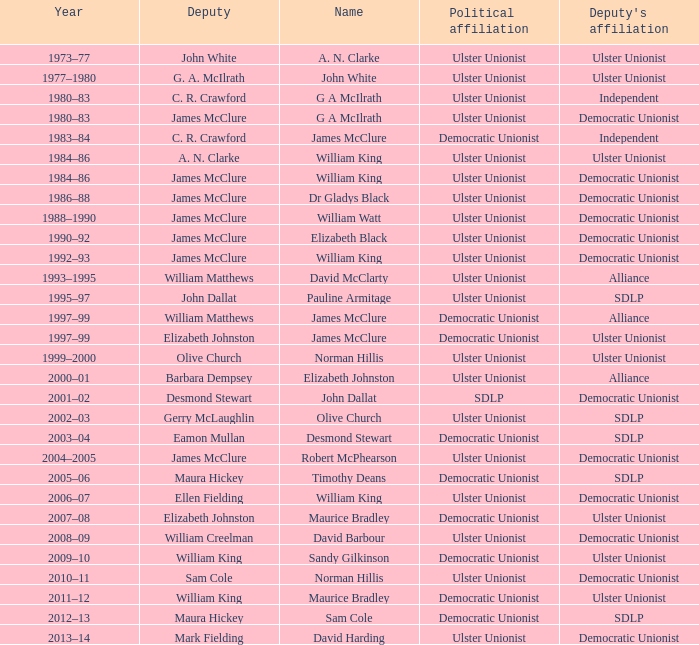Parse the full table. {'header': ['Year', 'Deputy', 'Name', 'Political affiliation', "Deputy's affiliation"], 'rows': [['1973–77', 'John White', 'A. N. Clarke', 'Ulster Unionist', 'Ulster Unionist'], ['1977–1980', 'G. A. McIlrath', 'John White', 'Ulster Unionist', 'Ulster Unionist'], ['1980–83', 'C. R. Crawford', 'G A McIlrath', 'Ulster Unionist', 'Independent'], ['1980–83', 'James McClure', 'G A McIlrath', 'Ulster Unionist', 'Democratic Unionist'], ['1983–84', 'C. R. Crawford', 'James McClure', 'Democratic Unionist', 'Independent'], ['1984–86', 'A. N. Clarke', 'William King', 'Ulster Unionist', 'Ulster Unionist'], ['1984–86', 'James McClure', 'William King', 'Ulster Unionist', 'Democratic Unionist'], ['1986–88', 'James McClure', 'Dr Gladys Black', 'Ulster Unionist', 'Democratic Unionist'], ['1988–1990', 'James McClure', 'William Watt', 'Ulster Unionist', 'Democratic Unionist'], ['1990–92', 'James McClure', 'Elizabeth Black', 'Ulster Unionist', 'Democratic Unionist'], ['1992–93', 'James McClure', 'William King', 'Ulster Unionist', 'Democratic Unionist'], ['1993–1995', 'William Matthews', 'David McClarty', 'Ulster Unionist', 'Alliance'], ['1995–97', 'John Dallat', 'Pauline Armitage', 'Ulster Unionist', 'SDLP'], ['1997–99', 'William Matthews', 'James McClure', 'Democratic Unionist', 'Alliance'], ['1997–99', 'Elizabeth Johnston', 'James McClure', 'Democratic Unionist', 'Ulster Unionist'], ['1999–2000', 'Olive Church', 'Norman Hillis', 'Ulster Unionist', 'Ulster Unionist'], ['2000–01', 'Barbara Dempsey', 'Elizabeth Johnston', 'Ulster Unionist', 'Alliance'], ['2001–02', 'Desmond Stewart', 'John Dallat', 'SDLP', 'Democratic Unionist'], ['2002–03', 'Gerry McLaughlin', 'Olive Church', 'Ulster Unionist', 'SDLP'], ['2003–04', 'Eamon Mullan', 'Desmond Stewart', 'Democratic Unionist', 'SDLP'], ['2004–2005', 'James McClure', 'Robert McPhearson', 'Ulster Unionist', 'Democratic Unionist'], ['2005–06', 'Maura Hickey', 'Timothy Deans', 'Democratic Unionist', 'SDLP'], ['2006–07', 'Ellen Fielding', 'William King', 'Ulster Unionist', 'Democratic Unionist'], ['2007–08', 'Elizabeth Johnston', 'Maurice Bradley', 'Democratic Unionist', 'Ulster Unionist'], ['2008–09', 'William Creelman', 'David Barbour', 'Ulster Unionist', 'Democratic Unionist'], ['2009–10', 'William King', 'Sandy Gilkinson', 'Democratic Unionist', 'Ulster Unionist'], ['2010–11', 'Sam Cole', 'Norman Hillis', 'Ulster Unionist', 'Democratic Unionist'], ['2011–12', 'William King', 'Maurice Bradley', 'Democratic Unionist', 'Ulster Unionist'], ['2012–13', 'Maura Hickey', 'Sam Cole', 'Democratic Unionist', 'SDLP'], ['2013–14', 'Mark Fielding', 'David Harding', 'Ulster Unionist', 'Democratic Unionist']]} What is the designation of the deputy during 1992-93? James McClure. 